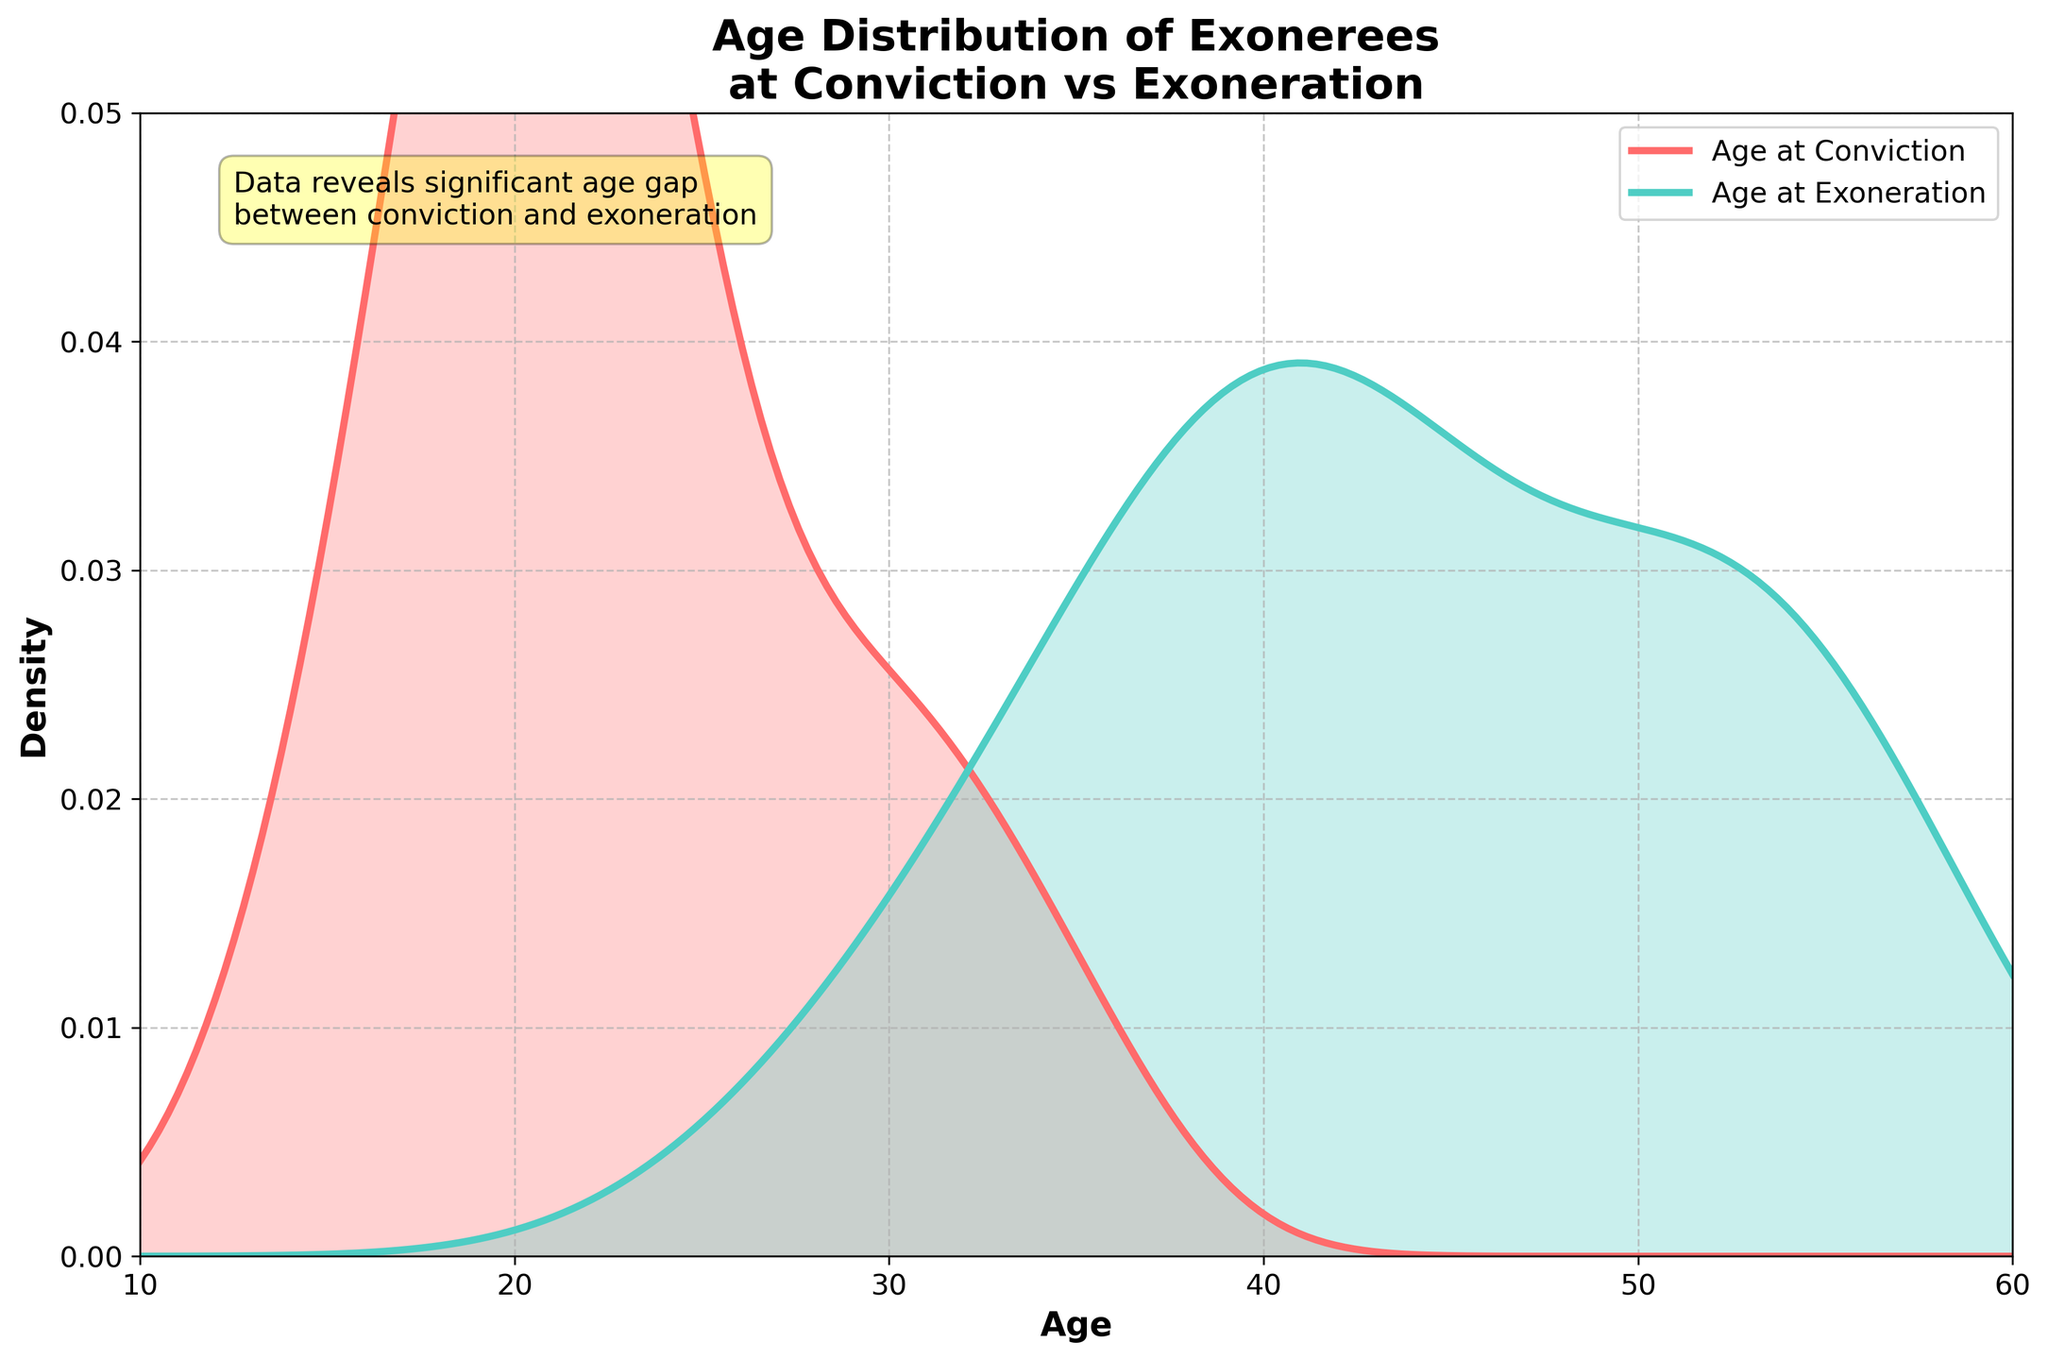What is the title of the plot? The title is prominently displayed at the top of the figure which provides a summary of what the plot is about. It reads, "Age Distribution of Exonerees at Conviction vs Exoneration".
Answer: Age Distribution of Exonerees at Conviction vs Exoneration What colors represent the age distribution at conviction and exoneration? Observing the plot, the distribution for age at conviction is shown in a red curve with shading, while the distribution for age at exoneration is depicted in a greenish-blue curve with shading.
Answer: Red for conviction, greenish-blue for exoneration What is the age range displayed on the x-axis? The x-axis displays values from 10 to 60, showing the span of ages being analyzed in the plot.
Answer: 10 to 60 Which distribution shows a higher density around age 20? By comparing the heights of the two density curves at around age 20, the red curve (age at conviction) is higher, indicating a greater density.
Answer: Age at conviction How does the peak density value of age at exoneration compare to age at conviction? The peak of the greenish-blue curve (age at exoneration) is higher than the peak of the red curve (age at conviction), indicating that the density of ages is higher at the peak for exoneration.
Answer: Higher for exoneration What is a significant visual insight provided in the annotation box? The text annotation highlights a significant age gap between conviction and exoneration, emphasizing the time lost due to wrongful convictions.
Answer: Significant age gap between conviction and exoneration At which age do we see the lowest density value in the age at exoneration distribution? By examining the greenish-blue curve, the lowest density appears around the age of 28.
Answer: Around age 28 How does the density of ages at conviction around age 30 compare to the density of ages at exoneration? Around age 30, the red curve (age at conviction) appears to be lower than the greenish-blue curve (age at exoneration), indicating a lesser density of convictions at this age.
Answer: Lower for conviction What can you infer about the ages most people were wrongly convicted and exonerated? Comparing the two curves, the red density curve (age at conviction) peaks around the early 20s, while the greenish-blue curve (age at exoneration) peaks around the late 30s to early 40s, indicating a significant time between conviction and exoneration.
Answer: Conviction early 20s, exoneration late 30s to early 40s What is the range of densities (y-axis values) for both distributions? The density values range between 0 and approximately 0.045 for both distributions, as indicated by the y-axis limits.
Answer: 0 to 0.045 